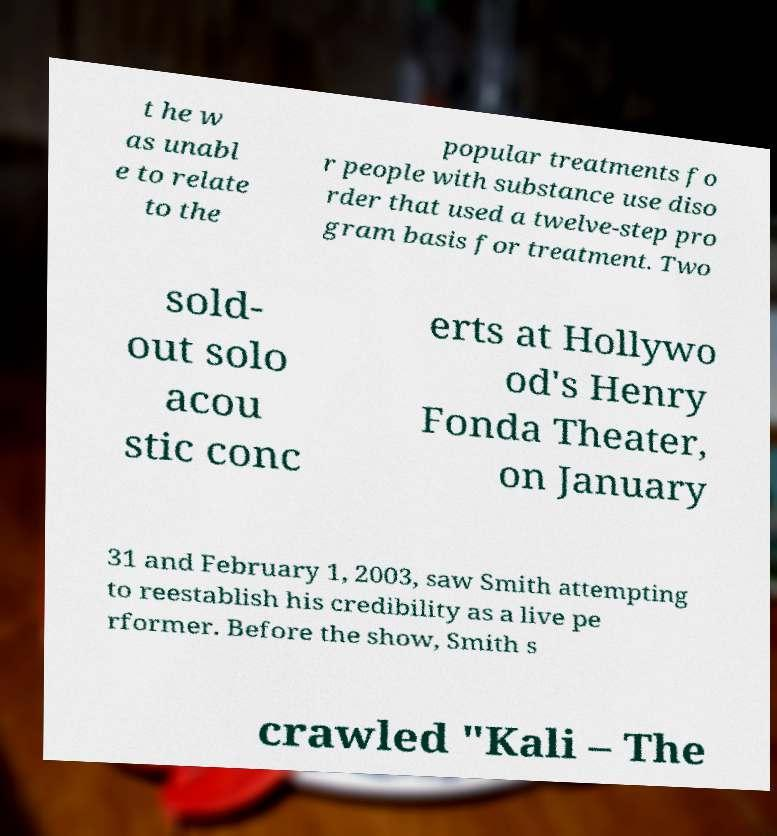Could you extract and type out the text from this image? t he w as unabl e to relate to the popular treatments fo r people with substance use diso rder that used a twelve-step pro gram basis for treatment. Two sold- out solo acou stic conc erts at Hollywo od's Henry Fonda Theater, on January 31 and February 1, 2003, saw Smith attempting to reestablish his credibility as a live pe rformer. Before the show, Smith s crawled "Kali – The 